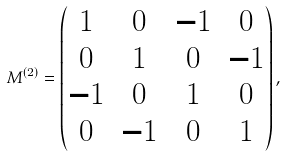Convert formula to latex. <formula><loc_0><loc_0><loc_500><loc_500>M ^ { ( 2 ) } = \begin{pmatrix} 1 & 0 & - 1 & 0 \\ 0 & 1 & 0 & - 1 \\ - 1 & 0 & 1 & 0 \\ 0 & - 1 & 0 & 1 \end{pmatrix} ,</formula> 